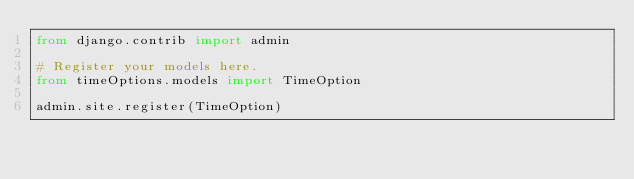<code> <loc_0><loc_0><loc_500><loc_500><_Python_>from django.contrib import admin

# Register your models here.
from timeOptions.models import TimeOption

admin.site.register(TimeOption)
</code> 